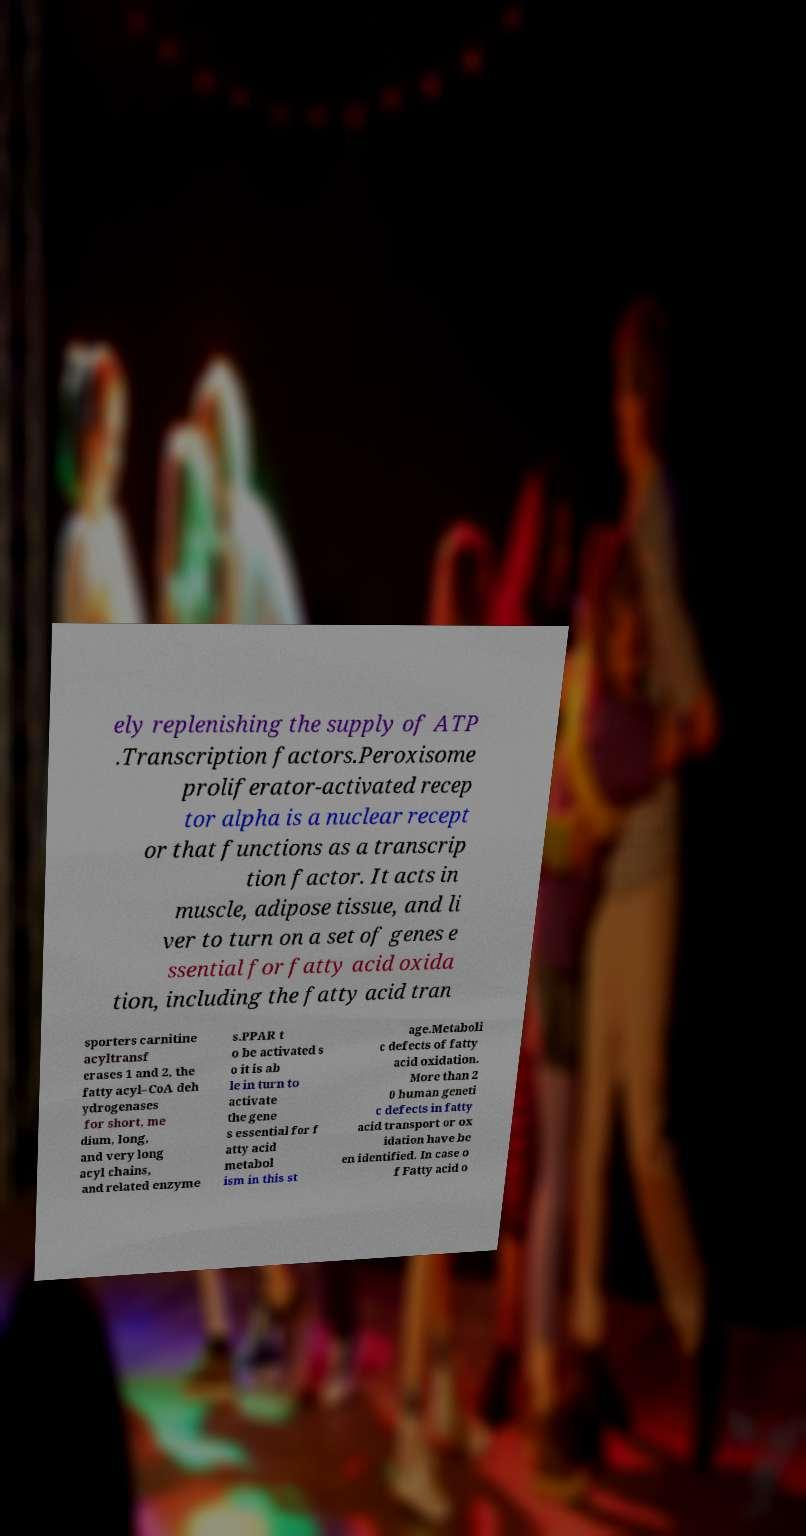Could you extract and type out the text from this image? ely replenishing the supply of ATP .Transcription factors.Peroxisome proliferator-activated recep tor alpha is a nuclear recept or that functions as a transcrip tion factor. It acts in muscle, adipose tissue, and li ver to turn on a set of genes e ssential for fatty acid oxida tion, including the fatty acid tran sporters carnitine acyltransf erases 1 and 2, the fatty acyl–CoA deh ydrogenases for short, me dium, long, and very long acyl chains, and related enzyme s.PPAR t o be activated s o it is ab le in turn to activate the gene s essential for f atty acid metabol ism in this st age.Metaboli c defects of fatty acid oxidation. More than 2 0 human geneti c defects in fatty acid transport or ox idation have be en identified. In case o f Fatty acid o 